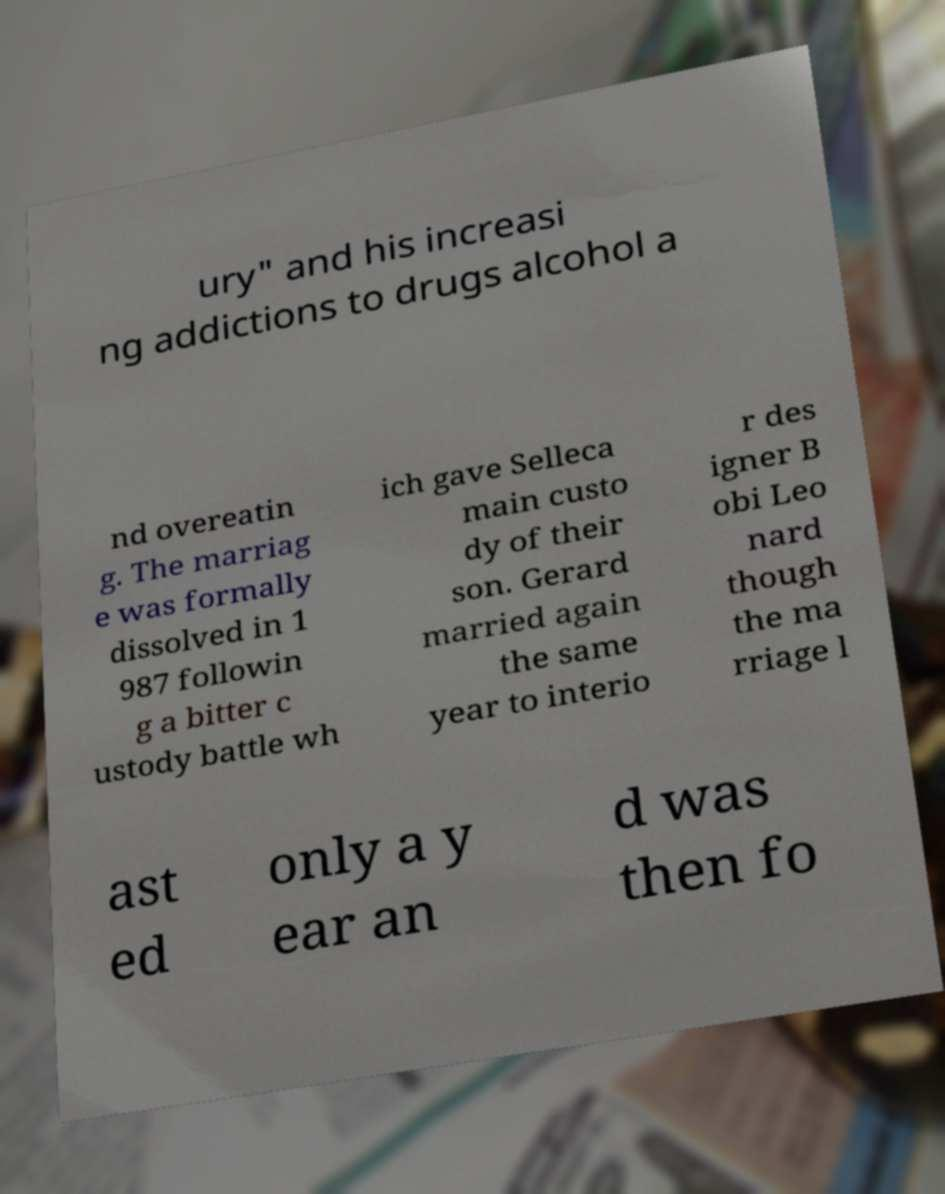I need the written content from this picture converted into text. Can you do that? ury" and his increasi ng addictions to drugs alcohol a nd overeatin g. The marriag e was formally dissolved in 1 987 followin g a bitter c ustody battle wh ich gave Selleca main custo dy of their son. Gerard married again the same year to interio r des igner B obi Leo nard though the ma rriage l ast ed only a y ear an d was then fo 